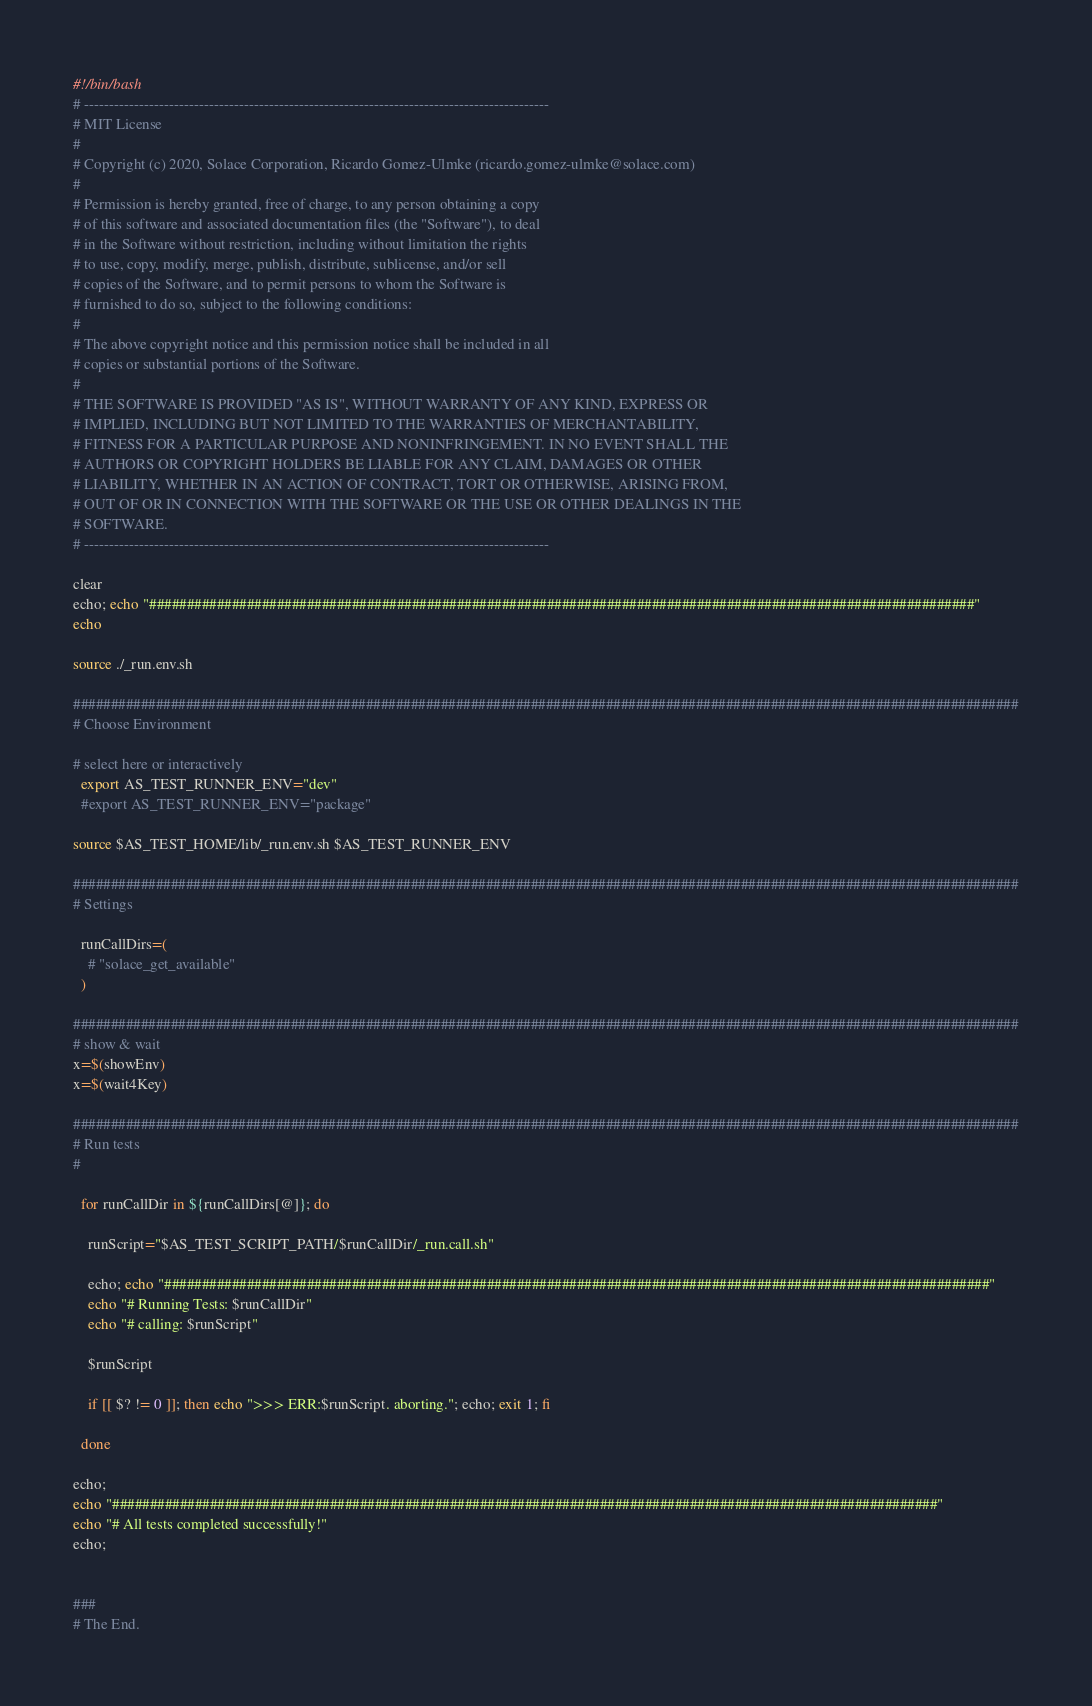<code> <loc_0><loc_0><loc_500><loc_500><_Bash_>#!/bin/bash
# ---------------------------------------------------------------------------------------------
# MIT License
#
# Copyright (c) 2020, Solace Corporation, Ricardo Gomez-Ulmke (ricardo.gomez-ulmke@solace.com)
#
# Permission is hereby granted, free of charge, to any person obtaining a copy
# of this software and associated documentation files (the "Software"), to deal
# in the Software without restriction, including without limitation the rights
# to use, copy, modify, merge, publish, distribute, sublicense, and/or sell
# copies of the Software, and to permit persons to whom the Software is
# furnished to do so, subject to the following conditions:
#
# The above copyright notice and this permission notice shall be included in all
# copies or substantial portions of the Software.
#
# THE SOFTWARE IS PROVIDED "AS IS", WITHOUT WARRANTY OF ANY KIND, EXPRESS OR
# IMPLIED, INCLUDING BUT NOT LIMITED TO THE WARRANTIES OF MERCHANTABILITY,
# FITNESS FOR A PARTICULAR PURPOSE AND NONINFRINGEMENT. IN NO EVENT SHALL THE
# AUTHORS OR COPYRIGHT HOLDERS BE LIABLE FOR ANY CLAIM, DAMAGES OR OTHER
# LIABILITY, WHETHER IN AN ACTION OF CONTRACT, TORT OR OTHERWISE, ARISING FROM,
# OUT OF OR IN CONNECTION WITH THE SOFTWARE OR THE USE OR OTHER DEALINGS IN THE
# SOFTWARE.
# ---------------------------------------------------------------------------------------------

clear
echo; echo "##############################################################################################################"
echo

source ./_run.env.sh

##############################################################################################################################
# Choose Environment

# select here or interactively
  export AS_TEST_RUNNER_ENV="dev"
  #export AS_TEST_RUNNER_ENV="package"

source $AS_TEST_HOME/lib/_run.env.sh $AS_TEST_RUNNER_ENV

##############################################################################################################################
# Settings

  runCallDirs=(
    # "solace_get_available"
  )

##############################################################################################################################
# show & wait
x=$(showEnv)
x=$(wait4Key)

##############################################################################################################################
# Run tests
#

  for runCallDir in ${runCallDirs[@]}; do

    runScript="$AS_TEST_SCRIPT_PATH/$runCallDir/_run.call.sh"

    echo; echo "##############################################################################################################"
    echo "# Running Tests: $runCallDir"
    echo "# calling: $runScript"

    $runScript

    if [[ $? != 0 ]]; then echo ">>> ERR:$runScript. aborting."; echo; exit 1; fi

  done

echo;
echo "##############################################################################################################"
echo "# All tests completed successfully!"
echo;


###
# The End.
</code> 